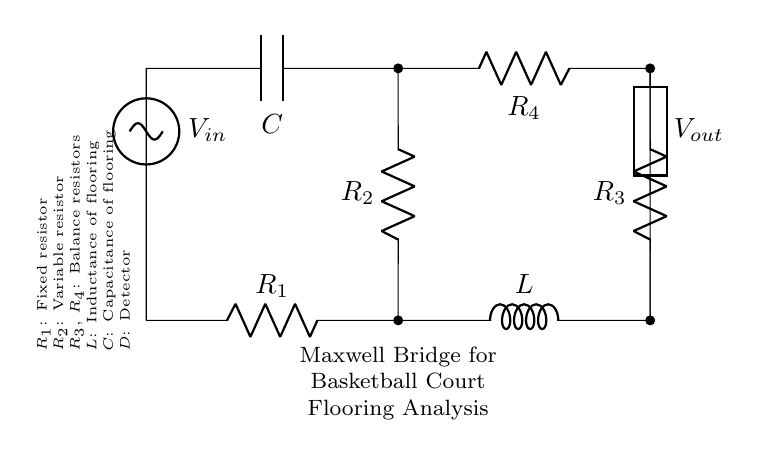What type of bridge is shown in the circuit? This circuit is a Maxwell Bridge, which is used for measuring the unknown inductance by balancing a bridge circuit. The diagram indicates its purpose through the label in the node.
Answer: Maxwell Bridge How many resistors are in the circuit? The circuit has four resistors: one fixed resistor, one variable resistor, and two balance resistors. Each resistor is clearly labeled in the diagram.
Answer: Four What component represents the inductance of flooring? The inductance represented in the circuit is denoted by the component labeled as 'L', indicating its role in the analysis of the flooring's characteristics.
Answer: L What does the variable resistor control in the circuit? The variable resistor, labeled as 'R2', allows for the adjustment of balance in the bridge, which is crucial for measuring the dynamic properties of the basketball court flooring.
Answer: Balance What is the role of the capacitor in this circuit? The capacitor, marked 'C', represents the capacitance of the flooring, contributing to the overall impedance and allowing for the dynamic properties analysis in conjunction with the inductance and resistors.
Answer: Capacitance What is detected by component D? Component 'D', labeled as the detector, observes the output voltage from the bridge circuit to determine the balance condition, essential for obtaining the values sought from the analysis.
Answer: Output voltage What kind of source is used to power this Maxwell bridge? The circuit uses a sinusoidal voltage source labeled as 'Vin', which provides the alternating current necessary for the bridge's operation and analysis of flooring properties.
Answer: Sinusoidal voltage source 